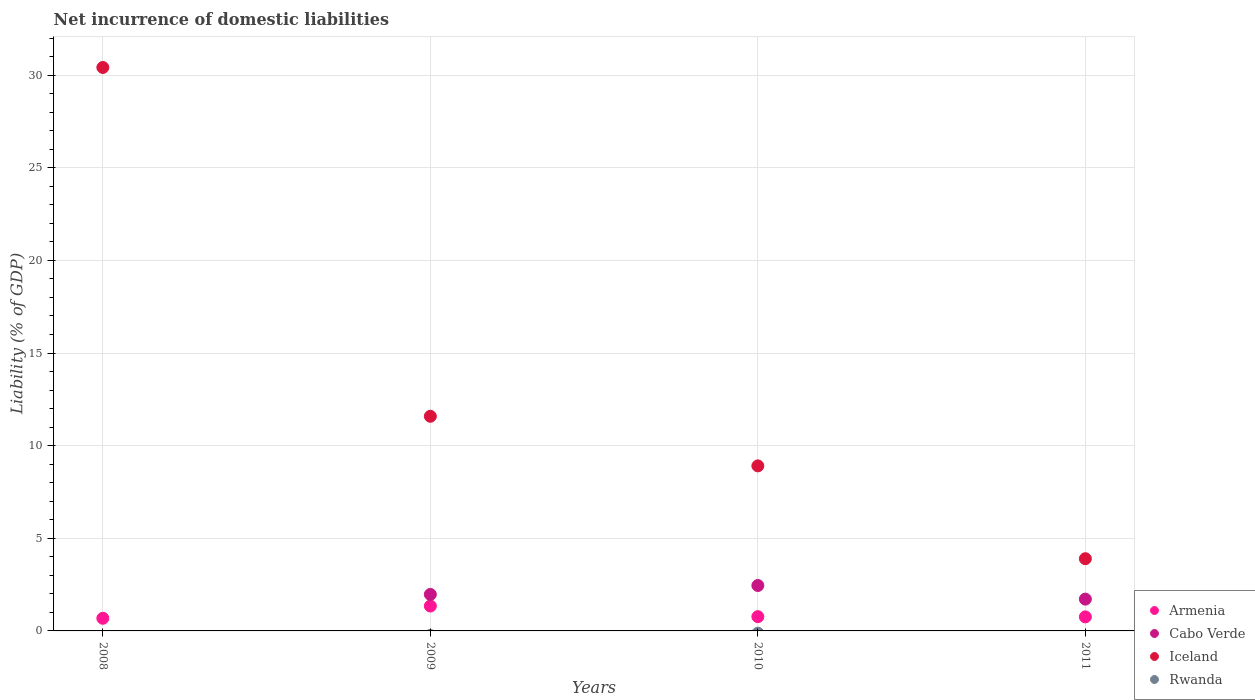How many different coloured dotlines are there?
Offer a very short reply. 3. What is the net incurrence of domestic liabilities in Iceland in 2009?
Provide a succinct answer. 11.59. Across all years, what is the maximum net incurrence of domestic liabilities in Armenia?
Keep it short and to the point. 1.34. Across all years, what is the minimum net incurrence of domestic liabilities in Iceland?
Your answer should be very brief. 3.9. What is the total net incurrence of domestic liabilities in Cabo Verde in the graph?
Your answer should be compact. 6.14. What is the difference between the net incurrence of domestic liabilities in Iceland in 2009 and that in 2011?
Give a very brief answer. 7.69. What is the difference between the net incurrence of domestic liabilities in Rwanda in 2011 and the net incurrence of domestic liabilities in Armenia in 2010?
Provide a short and direct response. -0.77. What is the average net incurrence of domestic liabilities in Cabo Verde per year?
Your answer should be very brief. 1.53. In the year 2011, what is the difference between the net incurrence of domestic liabilities in Iceland and net incurrence of domestic liabilities in Armenia?
Your answer should be compact. 3.14. In how many years, is the net incurrence of domestic liabilities in Iceland greater than 13 %?
Provide a short and direct response. 1. What is the ratio of the net incurrence of domestic liabilities in Iceland in 2010 to that in 2011?
Provide a short and direct response. 2.29. Is the difference between the net incurrence of domestic liabilities in Iceland in 2008 and 2011 greater than the difference between the net incurrence of domestic liabilities in Armenia in 2008 and 2011?
Offer a very short reply. Yes. What is the difference between the highest and the second highest net incurrence of domestic liabilities in Cabo Verde?
Ensure brevity in your answer.  0.48. What is the difference between the highest and the lowest net incurrence of domestic liabilities in Armenia?
Keep it short and to the point. 0.66. Is it the case that in every year, the sum of the net incurrence of domestic liabilities in Cabo Verde and net incurrence of domestic liabilities in Armenia  is greater than the net incurrence of domestic liabilities in Iceland?
Keep it short and to the point. No. Is the net incurrence of domestic liabilities in Rwanda strictly greater than the net incurrence of domestic liabilities in Iceland over the years?
Offer a terse response. No. How many years are there in the graph?
Your response must be concise. 4. Are the values on the major ticks of Y-axis written in scientific E-notation?
Provide a succinct answer. No. Does the graph contain any zero values?
Offer a very short reply. Yes. Does the graph contain grids?
Offer a terse response. Yes. How are the legend labels stacked?
Offer a terse response. Vertical. What is the title of the graph?
Provide a short and direct response. Net incurrence of domestic liabilities. Does "Suriname" appear as one of the legend labels in the graph?
Provide a short and direct response. No. What is the label or title of the Y-axis?
Offer a very short reply. Liability (% of GDP). What is the Liability (% of GDP) of Armenia in 2008?
Your answer should be compact. 0.68. What is the Liability (% of GDP) of Cabo Verde in 2008?
Your answer should be compact. 0. What is the Liability (% of GDP) of Iceland in 2008?
Make the answer very short. 30.41. What is the Liability (% of GDP) of Rwanda in 2008?
Your answer should be very brief. 0. What is the Liability (% of GDP) in Armenia in 2009?
Keep it short and to the point. 1.34. What is the Liability (% of GDP) of Cabo Verde in 2009?
Make the answer very short. 1.97. What is the Liability (% of GDP) of Iceland in 2009?
Your answer should be compact. 11.59. What is the Liability (% of GDP) of Armenia in 2010?
Give a very brief answer. 0.77. What is the Liability (% of GDP) of Cabo Verde in 2010?
Your response must be concise. 2.45. What is the Liability (% of GDP) of Iceland in 2010?
Offer a terse response. 8.91. What is the Liability (% of GDP) of Rwanda in 2010?
Provide a succinct answer. 0. What is the Liability (% of GDP) of Armenia in 2011?
Give a very brief answer. 0.76. What is the Liability (% of GDP) of Cabo Verde in 2011?
Ensure brevity in your answer.  1.72. What is the Liability (% of GDP) of Iceland in 2011?
Your answer should be compact. 3.9. What is the Liability (% of GDP) of Rwanda in 2011?
Your response must be concise. 0. Across all years, what is the maximum Liability (% of GDP) in Armenia?
Keep it short and to the point. 1.34. Across all years, what is the maximum Liability (% of GDP) in Cabo Verde?
Your answer should be very brief. 2.45. Across all years, what is the maximum Liability (% of GDP) of Iceland?
Keep it short and to the point. 30.41. Across all years, what is the minimum Liability (% of GDP) in Armenia?
Make the answer very short. 0.68. Across all years, what is the minimum Liability (% of GDP) of Cabo Verde?
Provide a succinct answer. 0. Across all years, what is the minimum Liability (% of GDP) of Iceland?
Give a very brief answer. 3.9. What is the total Liability (% of GDP) in Armenia in the graph?
Offer a terse response. 3.55. What is the total Liability (% of GDP) in Cabo Verde in the graph?
Provide a succinct answer. 6.14. What is the total Liability (% of GDP) of Iceland in the graph?
Offer a terse response. 54.81. What is the total Liability (% of GDP) of Rwanda in the graph?
Give a very brief answer. 0. What is the difference between the Liability (% of GDP) in Armenia in 2008 and that in 2009?
Keep it short and to the point. -0.66. What is the difference between the Liability (% of GDP) of Iceland in 2008 and that in 2009?
Your response must be concise. 18.83. What is the difference between the Liability (% of GDP) in Armenia in 2008 and that in 2010?
Provide a short and direct response. -0.09. What is the difference between the Liability (% of GDP) of Iceland in 2008 and that in 2010?
Offer a very short reply. 21.51. What is the difference between the Liability (% of GDP) of Armenia in 2008 and that in 2011?
Offer a very short reply. -0.08. What is the difference between the Liability (% of GDP) of Iceland in 2008 and that in 2011?
Your answer should be compact. 26.52. What is the difference between the Liability (% of GDP) of Armenia in 2009 and that in 2010?
Your answer should be very brief. 0.57. What is the difference between the Liability (% of GDP) in Cabo Verde in 2009 and that in 2010?
Your answer should be compact. -0.48. What is the difference between the Liability (% of GDP) in Iceland in 2009 and that in 2010?
Offer a very short reply. 2.68. What is the difference between the Liability (% of GDP) of Armenia in 2009 and that in 2011?
Give a very brief answer. 0.59. What is the difference between the Liability (% of GDP) in Cabo Verde in 2009 and that in 2011?
Provide a short and direct response. 0.25. What is the difference between the Liability (% of GDP) in Iceland in 2009 and that in 2011?
Make the answer very short. 7.69. What is the difference between the Liability (% of GDP) in Armenia in 2010 and that in 2011?
Ensure brevity in your answer.  0.01. What is the difference between the Liability (% of GDP) in Cabo Verde in 2010 and that in 2011?
Your answer should be very brief. 0.74. What is the difference between the Liability (% of GDP) of Iceland in 2010 and that in 2011?
Provide a short and direct response. 5.01. What is the difference between the Liability (% of GDP) of Armenia in 2008 and the Liability (% of GDP) of Cabo Verde in 2009?
Keep it short and to the point. -1.29. What is the difference between the Liability (% of GDP) of Armenia in 2008 and the Liability (% of GDP) of Iceland in 2009?
Give a very brief answer. -10.9. What is the difference between the Liability (% of GDP) in Armenia in 2008 and the Liability (% of GDP) in Cabo Verde in 2010?
Make the answer very short. -1.77. What is the difference between the Liability (% of GDP) in Armenia in 2008 and the Liability (% of GDP) in Iceland in 2010?
Your response must be concise. -8.23. What is the difference between the Liability (% of GDP) of Armenia in 2008 and the Liability (% of GDP) of Cabo Verde in 2011?
Your response must be concise. -1.03. What is the difference between the Liability (% of GDP) of Armenia in 2008 and the Liability (% of GDP) of Iceland in 2011?
Your answer should be compact. -3.22. What is the difference between the Liability (% of GDP) in Armenia in 2009 and the Liability (% of GDP) in Cabo Verde in 2010?
Your answer should be very brief. -1.11. What is the difference between the Liability (% of GDP) in Armenia in 2009 and the Liability (% of GDP) in Iceland in 2010?
Offer a very short reply. -7.57. What is the difference between the Liability (% of GDP) in Cabo Verde in 2009 and the Liability (% of GDP) in Iceland in 2010?
Ensure brevity in your answer.  -6.94. What is the difference between the Liability (% of GDP) of Armenia in 2009 and the Liability (% of GDP) of Cabo Verde in 2011?
Your response must be concise. -0.37. What is the difference between the Liability (% of GDP) of Armenia in 2009 and the Liability (% of GDP) of Iceland in 2011?
Your answer should be compact. -2.55. What is the difference between the Liability (% of GDP) in Cabo Verde in 2009 and the Liability (% of GDP) in Iceland in 2011?
Keep it short and to the point. -1.93. What is the difference between the Liability (% of GDP) of Armenia in 2010 and the Liability (% of GDP) of Cabo Verde in 2011?
Your response must be concise. -0.95. What is the difference between the Liability (% of GDP) of Armenia in 2010 and the Liability (% of GDP) of Iceland in 2011?
Ensure brevity in your answer.  -3.13. What is the difference between the Liability (% of GDP) of Cabo Verde in 2010 and the Liability (% of GDP) of Iceland in 2011?
Ensure brevity in your answer.  -1.45. What is the average Liability (% of GDP) in Armenia per year?
Your answer should be very brief. 0.89. What is the average Liability (% of GDP) of Cabo Verde per year?
Offer a very short reply. 1.53. What is the average Liability (% of GDP) in Iceland per year?
Make the answer very short. 13.7. In the year 2008, what is the difference between the Liability (% of GDP) of Armenia and Liability (% of GDP) of Iceland?
Provide a succinct answer. -29.73. In the year 2009, what is the difference between the Liability (% of GDP) of Armenia and Liability (% of GDP) of Cabo Verde?
Keep it short and to the point. -0.63. In the year 2009, what is the difference between the Liability (% of GDP) of Armenia and Liability (% of GDP) of Iceland?
Your response must be concise. -10.24. In the year 2009, what is the difference between the Liability (% of GDP) in Cabo Verde and Liability (% of GDP) in Iceland?
Offer a very short reply. -9.62. In the year 2010, what is the difference between the Liability (% of GDP) in Armenia and Liability (% of GDP) in Cabo Verde?
Your answer should be compact. -1.68. In the year 2010, what is the difference between the Liability (% of GDP) of Armenia and Liability (% of GDP) of Iceland?
Ensure brevity in your answer.  -8.14. In the year 2010, what is the difference between the Liability (% of GDP) of Cabo Verde and Liability (% of GDP) of Iceland?
Provide a short and direct response. -6.46. In the year 2011, what is the difference between the Liability (% of GDP) in Armenia and Liability (% of GDP) in Cabo Verde?
Provide a short and direct response. -0.96. In the year 2011, what is the difference between the Liability (% of GDP) of Armenia and Liability (% of GDP) of Iceland?
Make the answer very short. -3.14. In the year 2011, what is the difference between the Liability (% of GDP) in Cabo Verde and Liability (% of GDP) in Iceland?
Provide a succinct answer. -2.18. What is the ratio of the Liability (% of GDP) in Armenia in 2008 to that in 2009?
Your response must be concise. 0.51. What is the ratio of the Liability (% of GDP) of Iceland in 2008 to that in 2009?
Your answer should be compact. 2.63. What is the ratio of the Liability (% of GDP) in Armenia in 2008 to that in 2010?
Ensure brevity in your answer.  0.89. What is the ratio of the Liability (% of GDP) in Iceland in 2008 to that in 2010?
Make the answer very short. 3.41. What is the ratio of the Liability (% of GDP) of Armenia in 2008 to that in 2011?
Offer a very short reply. 0.9. What is the ratio of the Liability (% of GDP) in Iceland in 2008 to that in 2011?
Offer a terse response. 7.8. What is the ratio of the Liability (% of GDP) in Armenia in 2009 to that in 2010?
Provide a short and direct response. 1.74. What is the ratio of the Liability (% of GDP) in Cabo Verde in 2009 to that in 2010?
Provide a short and direct response. 0.8. What is the ratio of the Liability (% of GDP) in Iceland in 2009 to that in 2010?
Your answer should be very brief. 1.3. What is the ratio of the Liability (% of GDP) of Armenia in 2009 to that in 2011?
Your answer should be very brief. 1.77. What is the ratio of the Liability (% of GDP) of Cabo Verde in 2009 to that in 2011?
Your answer should be very brief. 1.15. What is the ratio of the Liability (% of GDP) in Iceland in 2009 to that in 2011?
Offer a very short reply. 2.97. What is the ratio of the Liability (% of GDP) of Armenia in 2010 to that in 2011?
Keep it short and to the point. 1.02. What is the ratio of the Liability (% of GDP) in Cabo Verde in 2010 to that in 2011?
Your response must be concise. 1.43. What is the ratio of the Liability (% of GDP) of Iceland in 2010 to that in 2011?
Ensure brevity in your answer.  2.29. What is the difference between the highest and the second highest Liability (% of GDP) in Armenia?
Provide a short and direct response. 0.57. What is the difference between the highest and the second highest Liability (% of GDP) in Cabo Verde?
Your response must be concise. 0.48. What is the difference between the highest and the second highest Liability (% of GDP) in Iceland?
Make the answer very short. 18.83. What is the difference between the highest and the lowest Liability (% of GDP) in Armenia?
Ensure brevity in your answer.  0.66. What is the difference between the highest and the lowest Liability (% of GDP) in Cabo Verde?
Give a very brief answer. 2.45. What is the difference between the highest and the lowest Liability (% of GDP) in Iceland?
Your answer should be compact. 26.52. 